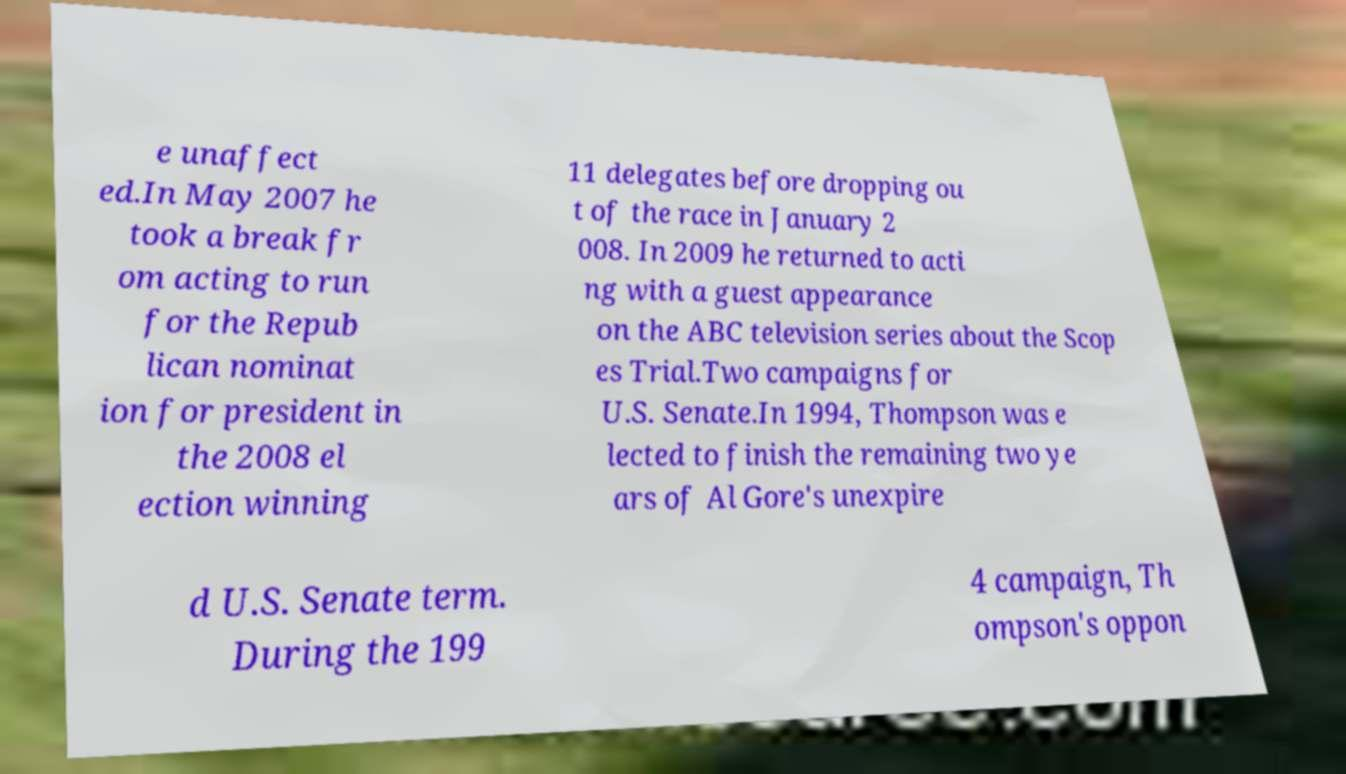Please identify and transcribe the text found in this image. e unaffect ed.In May 2007 he took a break fr om acting to run for the Repub lican nominat ion for president in the 2008 el ection winning 11 delegates before dropping ou t of the race in January 2 008. In 2009 he returned to acti ng with a guest appearance on the ABC television series about the Scop es Trial.Two campaigns for U.S. Senate.In 1994, Thompson was e lected to finish the remaining two ye ars of Al Gore's unexpire d U.S. Senate term. During the 199 4 campaign, Th ompson's oppon 